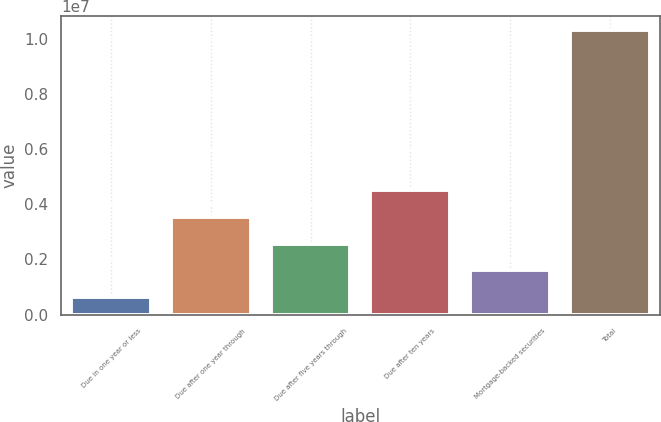Convert chart to OTSL. <chart><loc_0><loc_0><loc_500><loc_500><bar_chart><fcel>Due in one year or less<fcel>Due after one year through<fcel>Due after five years through<fcel>Due after ten years<fcel>Mortgage-backed securities<fcel>Total<nl><fcel>637105<fcel>3.54193e+06<fcel>2.57365e+06<fcel>4.5102e+06<fcel>1.60538e+06<fcel>1.03198e+07<nl></chart> 